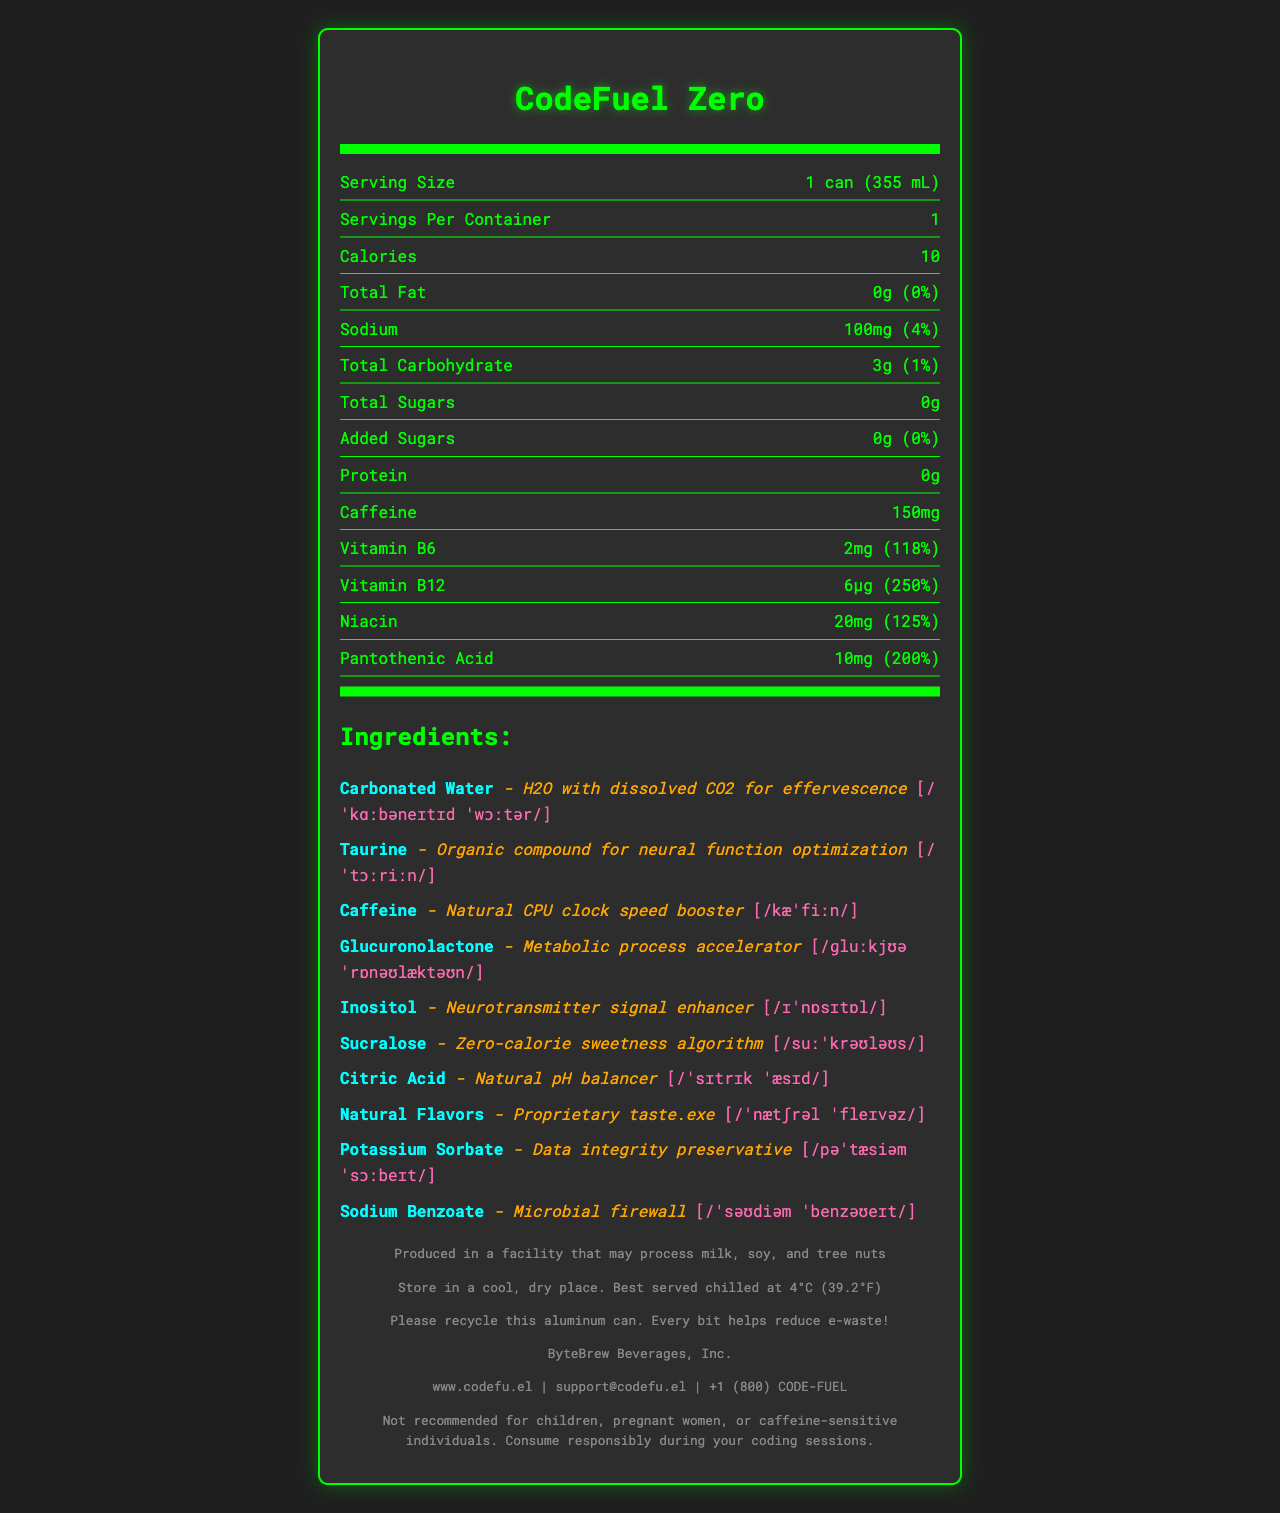what is the serving size? The serving size is indicated as "1 can (355 mL)" in the nutrition facts section.
Answer: 1 can (355 mL) How many calories are in the entire container? Since the serving size and servings per container are both 1, the total calories for the container are the same as the serving size, which is 10 calories.
Answer: 10 calories Which ingredient is described as "Natural CPU clock speed booster"? A. Carbonated Water B. Caffeine C. Sucralose D. Taurine In the document, Caffeine is described as "Natural CPU clock speed booster".
Answer: B. Caffeine What is the daily value percentage for Vitamin B12? The nutrition facts indicate that the daily value percentage for Vitamin B12 is 250%.
Answer: 250% Is there any protein in CodeFuel Zero? The document states that there is "0g" of protein in the energy drink.
Answer: No Which ingredient helps with "neural function optimization"? A. Taurine B. Inositol C. Glucuronolactone D. Sucralose The document describes Taurine as an ingredient for "neural function optimization".
Answer: A. Taurine How much caffeine does CodeFuel Zero contain? The nutrition facts list 150mg of caffeine.
Answer: 150mg Is CodeFuel Zero recommended for children? The disclaimer at the end states that it is "Not recommended for children".
Answer: No Which ingredient is used as a "Zero-calorie sweetness algorithm"? The ingredient Sucralose is described as a "Zero-calorie sweetness algorithm".
Answer: Sucralose How should CodeFuel Zero be stored? The storage instructions state "Store in a cool, dry place. Best served chilled at 4°C (39.2°F)".
Answer: Store in a cool, dry place. Best served chilled at 4°C (39.2°F). Is there any added sugar in CodeFuel Zero? The nutrition facts indicate that there are 0g of added sugars.
Answer: No What type of water is used in the ingredients? The document states one of the ingredients as "Carbonated Water".
Answer: Carbonated Water Who manufactures CodeFuel Zero? The document lists the manufacturer as "ByteBrew Beverages, Inc."
Answer: ByteBrew Beverages, Inc. What is the sodium content in one serving? The sodium content in one serving is listed as "100mg".
Answer: 100mg Does CodeFuel Zero contain any tree nuts? The allergen information states it is produced in a facility that may process tree nuts but does not confirm if it's an ingredient.
Answer: Cannot be determined Summarize the main details of the CodeFuel Zero energy drink. The main details include nutritional information, ingredients with their unique descriptions and pronunciations, allergen and storage info, and manufacturer details, all targeted toward a tech-savvy audience.
Answer: CodeFuel Zero is a low-calorie energy drink marketed to programmers, containing 10 calories, 150mg of caffeine, and various vitamins like B6 and B12. It features tech-themed ingredient descriptions and IPA pronunciations for mainly artificial sweeteners, preservatives, and other metabolic enhancers. The allergen info and storage instructions are provided, with recycling and manufacturer contact details included. The drink is not recommended for children, pregnant women, or caffeine-sensitive individuals. 